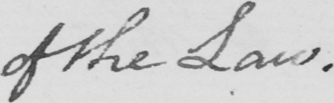What is written in this line of handwriting? of the Law . 